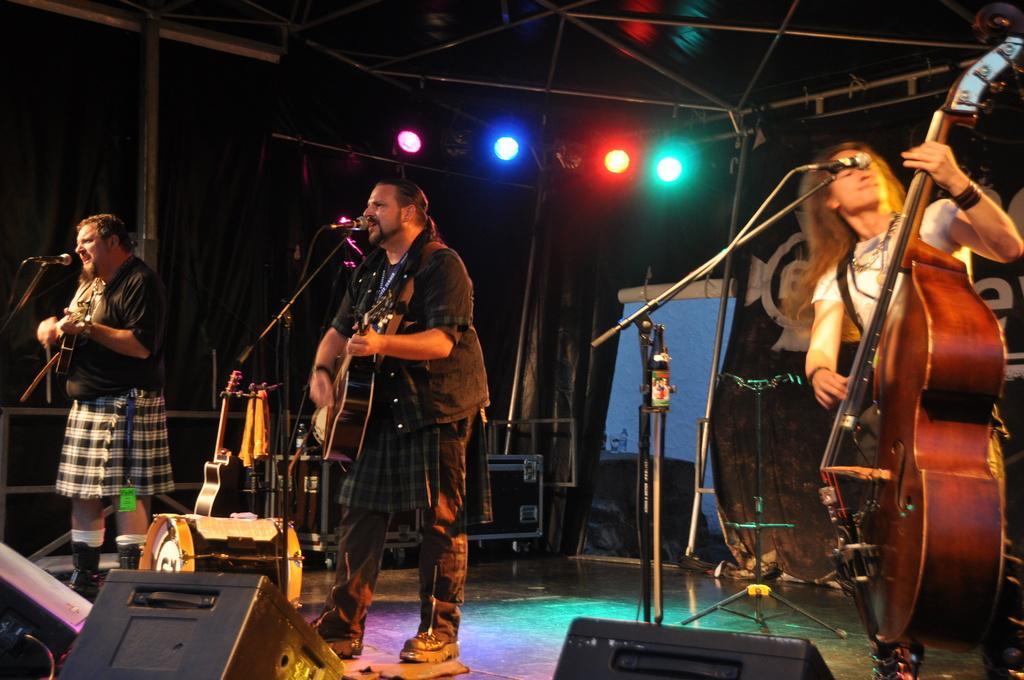How would you summarize this image in a sentence or two? In this picture there are three people, the man who is standing at the left side of the image, he is playing the guitar and singing in the mic and the second man who is standing at the center of the image, he is also playing the guitar and singing in the mic, the lady who is standing at the right side of the image she is playing the guitar and there is a mic in front of her, there are speakers on the stage and there are spotlights around the area of the image. 